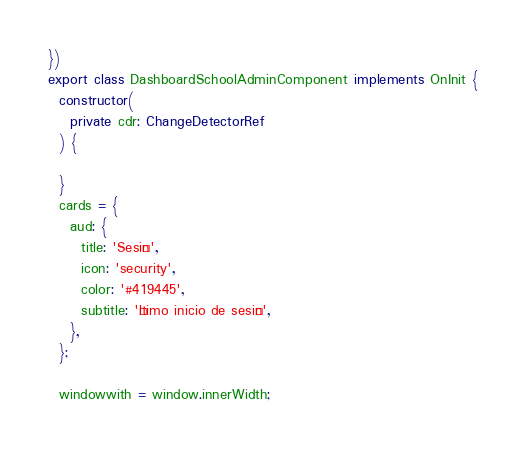Convert code to text. <code><loc_0><loc_0><loc_500><loc_500><_TypeScript_>})
export class DashboardSchoolAdminComponent implements OnInit {
  constructor(
    private cdr: ChangeDetectorRef
  ) {

  }
  cards = {
    aud: {
      title: 'Sesión',
      icon: 'security',
      color: '#419445',
      subtitle: 'Último inicio de sesión',
    },
  };

  windowwith = window.innerWidth;
</code> 